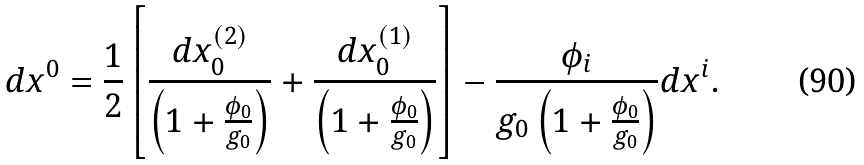<formula> <loc_0><loc_0><loc_500><loc_500>d x ^ { 0 } = \frac { 1 } { 2 } \left [ \frac { d x _ { 0 } ^ { ( 2 ) } } { \left ( 1 + \frac { \phi _ { 0 } } { g _ { 0 } } \right ) } + \frac { d x _ { 0 } ^ { ( 1 ) } } { \left ( 1 + \frac { \phi _ { 0 } } { g _ { 0 } } \right ) } \right ] - \frac { \phi _ { i } } { g _ { 0 } \left ( 1 + \frac { \phi _ { 0 } } { g _ { 0 } } \right ) } d x ^ { i } .</formula> 